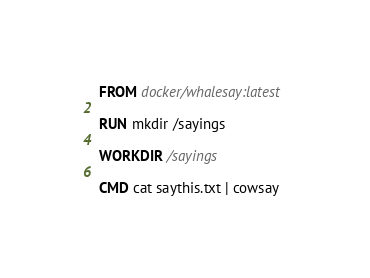Convert code to text. <code><loc_0><loc_0><loc_500><loc_500><_Dockerfile_>FROM docker/whalesay:latest

RUN mkdir /sayings

WORKDIR /sayings

CMD cat saythis.txt | cowsay
</code> 